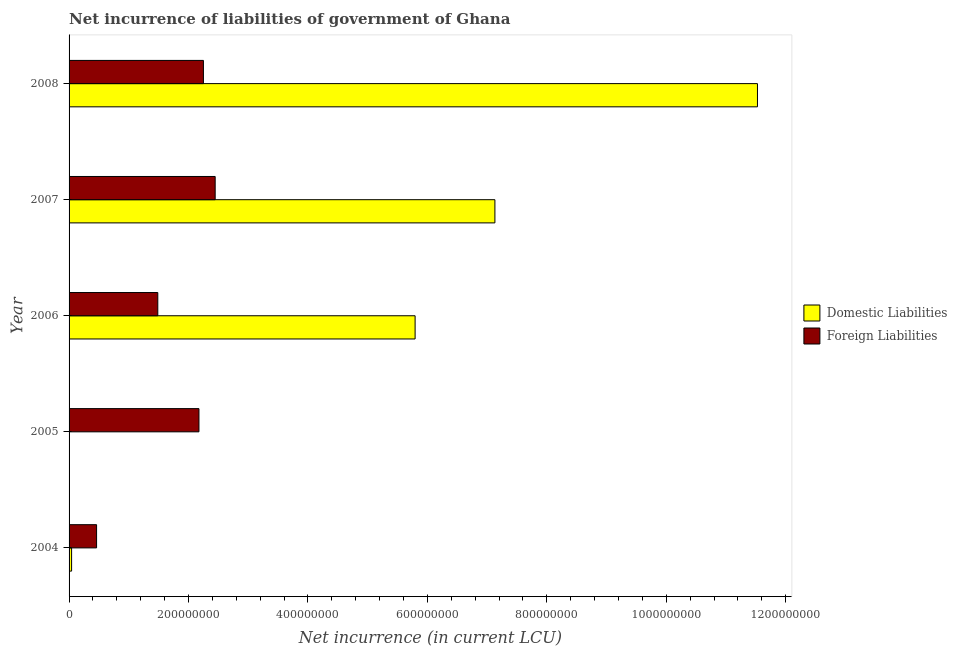How many different coloured bars are there?
Your answer should be compact. 2. Are the number of bars per tick equal to the number of legend labels?
Provide a short and direct response. No. Are the number of bars on each tick of the Y-axis equal?
Provide a succinct answer. No. How many bars are there on the 5th tick from the bottom?
Provide a short and direct response. 2. What is the net incurrence of foreign liabilities in 2006?
Ensure brevity in your answer.  1.49e+08. Across all years, what is the maximum net incurrence of foreign liabilities?
Provide a succinct answer. 2.45e+08. In which year was the net incurrence of foreign liabilities maximum?
Make the answer very short. 2007. What is the total net incurrence of domestic liabilities in the graph?
Offer a very short reply. 2.45e+09. What is the difference between the net incurrence of foreign liabilities in 2005 and that in 2006?
Your answer should be very brief. 6.89e+07. What is the difference between the net incurrence of domestic liabilities in 2008 and the net incurrence of foreign liabilities in 2007?
Ensure brevity in your answer.  9.08e+08. What is the average net incurrence of foreign liabilities per year?
Offer a terse response. 1.76e+08. In the year 2004, what is the difference between the net incurrence of domestic liabilities and net incurrence of foreign liabilities?
Offer a terse response. -4.18e+07. What is the ratio of the net incurrence of foreign liabilities in 2004 to that in 2006?
Ensure brevity in your answer.  0.31. What is the difference between the highest and the second highest net incurrence of foreign liabilities?
Your response must be concise. 1.97e+07. What is the difference between the highest and the lowest net incurrence of foreign liabilities?
Your answer should be very brief. 1.99e+08. In how many years, is the net incurrence of domestic liabilities greater than the average net incurrence of domestic liabilities taken over all years?
Keep it short and to the point. 3. Are all the bars in the graph horizontal?
Keep it short and to the point. Yes. How many years are there in the graph?
Provide a short and direct response. 5. What is the difference between two consecutive major ticks on the X-axis?
Make the answer very short. 2.00e+08. Are the values on the major ticks of X-axis written in scientific E-notation?
Provide a succinct answer. No. Does the graph contain any zero values?
Your answer should be compact. Yes. Where does the legend appear in the graph?
Your answer should be compact. Center right. How many legend labels are there?
Make the answer very short. 2. How are the legend labels stacked?
Offer a terse response. Vertical. What is the title of the graph?
Ensure brevity in your answer.  Net incurrence of liabilities of government of Ghana. Does "Crop" appear as one of the legend labels in the graph?
Provide a succinct answer. No. What is the label or title of the X-axis?
Your response must be concise. Net incurrence (in current LCU). What is the label or title of the Y-axis?
Your response must be concise. Year. What is the Net incurrence (in current LCU) of Domestic Liabilities in 2004?
Provide a short and direct response. 4.23e+06. What is the Net incurrence (in current LCU) of Foreign Liabilities in 2004?
Make the answer very short. 4.61e+07. What is the Net incurrence (in current LCU) in Foreign Liabilities in 2005?
Your response must be concise. 2.17e+08. What is the Net incurrence (in current LCU) of Domestic Liabilities in 2006?
Your answer should be compact. 5.79e+08. What is the Net incurrence (in current LCU) in Foreign Liabilities in 2006?
Keep it short and to the point. 1.49e+08. What is the Net incurrence (in current LCU) in Domestic Liabilities in 2007?
Offer a very short reply. 7.13e+08. What is the Net incurrence (in current LCU) in Foreign Liabilities in 2007?
Your answer should be compact. 2.45e+08. What is the Net incurrence (in current LCU) of Domestic Liabilities in 2008?
Ensure brevity in your answer.  1.15e+09. What is the Net incurrence (in current LCU) in Foreign Liabilities in 2008?
Ensure brevity in your answer.  2.25e+08. Across all years, what is the maximum Net incurrence (in current LCU) of Domestic Liabilities?
Provide a succinct answer. 1.15e+09. Across all years, what is the maximum Net incurrence (in current LCU) of Foreign Liabilities?
Your answer should be very brief. 2.45e+08. Across all years, what is the minimum Net incurrence (in current LCU) in Domestic Liabilities?
Offer a terse response. 0. Across all years, what is the minimum Net incurrence (in current LCU) of Foreign Liabilities?
Ensure brevity in your answer.  4.61e+07. What is the total Net incurrence (in current LCU) in Domestic Liabilities in the graph?
Offer a terse response. 2.45e+09. What is the total Net incurrence (in current LCU) of Foreign Liabilities in the graph?
Give a very brief answer. 8.82e+08. What is the difference between the Net incurrence (in current LCU) in Foreign Liabilities in 2004 and that in 2005?
Provide a succinct answer. -1.71e+08. What is the difference between the Net incurrence (in current LCU) of Domestic Liabilities in 2004 and that in 2006?
Provide a short and direct response. -5.75e+08. What is the difference between the Net incurrence (in current LCU) in Foreign Liabilities in 2004 and that in 2006?
Offer a terse response. -1.02e+08. What is the difference between the Net incurrence (in current LCU) of Domestic Liabilities in 2004 and that in 2007?
Provide a succinct answer. -7.09e+08. What is the difference between the Net incurrence (in current LCU) of Foreign Liabilities in 2004 and that in 2007?
Give a very brief answer. -1.99e+08. What is the difference between the Net incurrence (in current LCU) in Domestic Liabilities in 2004 and that in 2008?
Your answer should be very brief. -1.15e+09. What is the difference between the Net incurrence (in current LCU) in Foreign Liabilities in 2004 and that in 2008?
Offer a terse response. -1.79e+08. What is the difference between the Net incurrence (in current LCU) in Foreign Liabilities in 2005 and that in 2006?
Your answer should be very brief. 6.89e+07. What is the difference between the Net incurrence (in current LCU) of Foreign Liabilities in 2005 and that in 2007?
Provide a short and direct response. -2.72e+07. What is the difference between the Net incurrence (in current LCU) in Foreign Liabilities in 2005 and that in 2008?
Your response must be concise. -7.49e+06. What is the difference between the Net incurrence (in current LCU) in Domestic Liabilities in 2006 and that in 2007?
Ensure brevity in your answer.  -1.34e+08. What is the difference between the Net incurrence (in current LCU) in Foreign Liabilities in 2006 and that in 2007?
Your response must be concise. -9.61e+07. What is the difference between the Net incurrence (in current LCU) of Domestic Liabilities in 2006 and that in 2008?
Provide a succinct answer. -5.73e+08. What is the difference between the Net incurrence (in current LCU) in Foreign Liabilities in 2006 and that in 2008?
Keep it short and to the point. -7.64e+07. What is the difference between the Net incurrence (in current LCU) of Domestic Liabilities in 2007 and that in 2008?
Provide a short and direct response. -4.40e+08. What is the difference between the Net incurrence (in current LCU) in Foreign Liabilities in 2007 and that in 2008?
Make the answer very short. 1.97e+07. What is the difference between the Net incurrence (in current LCU) of Domestic Liabilities in 2004 and the Net incurrence (in current LCU) of Foreign Liabilities in 2005?
Give a very brief answer. -2.13e+08. What is the difference between the Net incurrence (in current LCU) of Domestic Liabilities in 2004 and the Net incurrence (in current LCU) of Foreign Liabilities in 2006?
Provide a short and direct response. -1.44e+08. What is the difference between the Net incurrence (in current LCU) in Domestic Liabilities in 2004 and the Net incurrence (in current LCU) in Foreign Liabilities in 2007?
Your answer should be very brief. -2.40e+08. What is the difference between the Net incurrence (in current LCU) in Domestic Liabilities in 2004 and the Net incurrence (in current LCU) in Foreign Liabilities in 2008?
Your response must be concise. -2.21e+08. What is the difference between the Net incurrence (in current LCU) of Domestic Liabilities in 2006 and the Net incurrence (in current LCU) of Foreign Liabilities in 2007?
Keep it short and to the point. 3.35e+08. What is the difference between the Net incurrence (in current LCU) of Domestic Liabilities in 2006 and the Net incurrence (in current LCU) of Foreign Liabilities in 2008?
Provide a succinct answer. 3.54e+08. What is the difference between the Net incurrence (in current LCU) of Domestic Liabilities in 2007 and the Net incurrence (in current LCU) of Foreign Liabilities in 2008?
Your response must be concise. 4.88e+08. What is the average Net incurrence (in current LCU) in Domestic Liabilities per year?
Provide a succinct answer. 4.90e+08. What is the average Net incurrence (in current LCU) of Foreign Liabilities per year?
Provide a short and direct response. 1.76e+08. In the year 2004, what is the difference between the Net incurrence (in current LCU) of Domestic Liabilities and Net incurrence (in current LCU) of Foreign Liabilities?
Ensure brevity in your answer.  -4.18e+07. In the year 2006, what is the difference between the Net incurrence (in current LCU) in Domestic Liabilities and Net incurrence (in current LCU) in Foreign Liabilities?
Provide a short and direct response. 4.31e+08. In the year 2007, what is the difference between the Net incurrence (in current LCU) of Domestic Liabilities and Net incurrence (in current LCU) of Foreign Liabilities?
Your answer should be compact. 4.68e+08. In the year 2008, what is the difference between the Net incurrence (in current LCU) in Domestic Liabilities and Net incurrence (in current LCU) in Foreign Liabilities?
Ensure brevity in your answer.  9.28e+08. What is the ratio of the Net incurrence (in current LCU) of Foreign Liabilities in 2004 to that in 2005?
Make the answer very short. 0.21. What is the ratio of the Net incurrence (in current LCU) in Domestic Liabilities in 2004 to that in 2006?
Provide a succinct answer. 0.01. What is the ratio of the Net incurrence (in current LCU) in Foreign Liabilities in 2004 to that in 2006?
Keep it short and to the point. 0.31. What is the ratio of the Net incurrence (in current LCU) of Domestic Liabilities in 2004 to that in 2007?
Provide a succinct answer. 0.01. What is the ratio of the Net incurrence (in current LCU) in Foreign Liabilities in 2004 to that in 2007?
Ensure brevity in your answer.  0.19. What is the ratio of the Net incurrence (in current LCU) in Domestic Liabilities in 2004 to that in 2008?
Give a very brief answer. 0. What is the ratio of the Net incurrence (in current LCU) of Foreign Liabilities in 2004 to that in 2008?
Offer a very short reply. 0.2. What is the ratio of the Net incurrence (in current LCU) in Foreign Liabilities in 2005 to that in 2006?
Keep it short and to the point. 1.46. What is the ratio of the Net incurrence (in current LCU) of Foreign Liabilities in 2005 to that in 2007?
Give a very brief answer. 0.89. What is the ratio of the Net incurrence (in current LCU) in Foreign Liabilities in 2005 to that in 2008?
Offer a very short reply. 0.97. What is the ratio of the Net incurrence (in current LCU) in Domestic Liabilities in 2006 to that in 2007?
Offer a terse response. 0.81. What is the ratio of the Net incurrence (in current LCU) of Foreign Liabilities in 2006 to that in 2007?
Your answer should be very brief. 0.61. What is the ratio of the Net incurrence (in current LCU) of Domestic Liabilities in 2006 to that in 2008?
Provide a short and direct response. 0.5. What is the ratio of the Net incurrence (in current LCU) of Foreign Liabilities in 2006 to that in 2008?
Ensure brevity in your answer.  0.66. What is the ratio of the Net incurrence (in current LCU) of Domestic Liabilities in 2007 to that in 2008?
Offer a terse response. 0.62. What is the ratio of the Net incurrence (in current LCU) of Foreign Liabilities in 2007 to that in 2008?
Keep it short and to the point. 1.09. What is the difference between the highest and the second highest Net incurrence (in current LCU) in Domestic Liabilities?
Give a very brief answer. 4.40e+08. What is the difference between the highest and the second highest Net incurrence (in current LCU) in Foreign Liabilities?
Your response must be concise. 1.97e+07. What is the difference between the highest and the lowest Net incurrence (in current LCU) of Domestic Liabilities?
Provide a succinct answer. 1.15e+09. What is the difference between the highest and the lowest Net incurrence (in current LCU) of Foreign Liabilities?
Provide a succinct answer. 1.99e+08. 